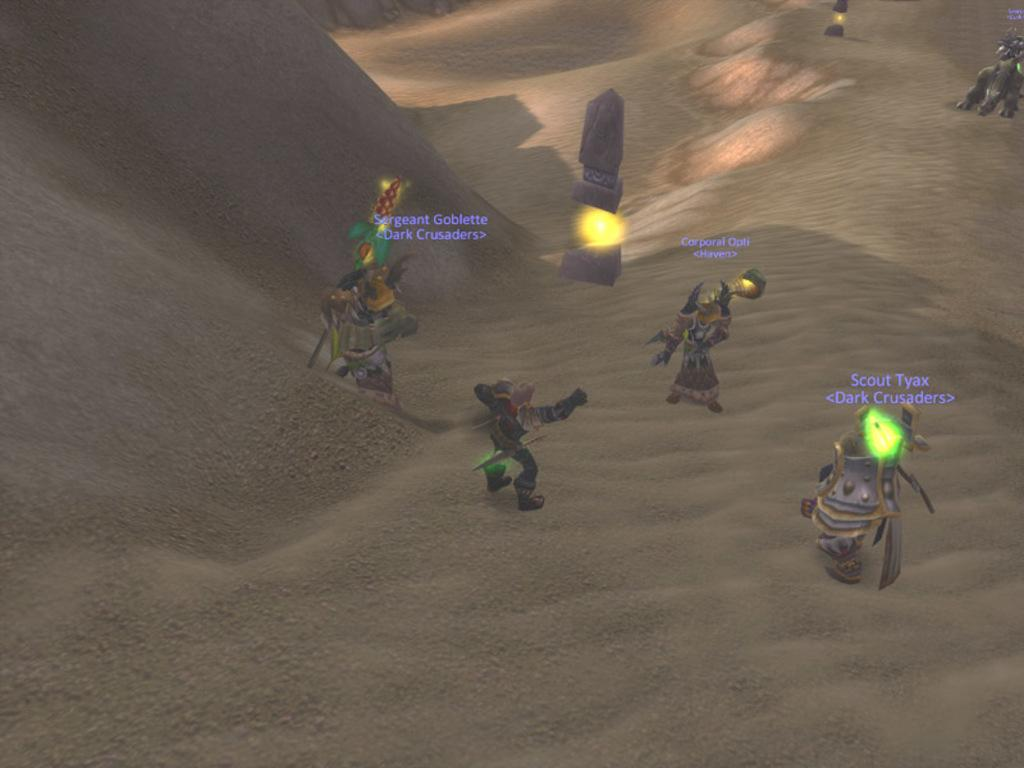What type of media does the image appear to be from? The image appears to be from an animated video game. What type of characters are present in the image? There are zombies in the image. What are the zombies holding in the image? The zombies are holding swords in the image. What type of geographical feature can be seen in the top left of the image? There is a mountain visible in the top left of the image. Can you describe the lighting in the image? There is light present in the image. What type of liquid is being used in the competition shown in the image? There is no competition present in the image, and no liquid is visible or mentioned in the provided facts. 